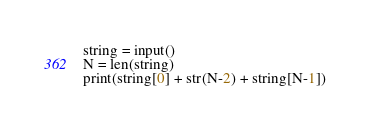Convert code to text. <code><loc_0><loc_0><loc_500><loc_500><_Python_>string = input()
N = len(string)
print(string[0] + str(N-2) + string[N-1])</code> 